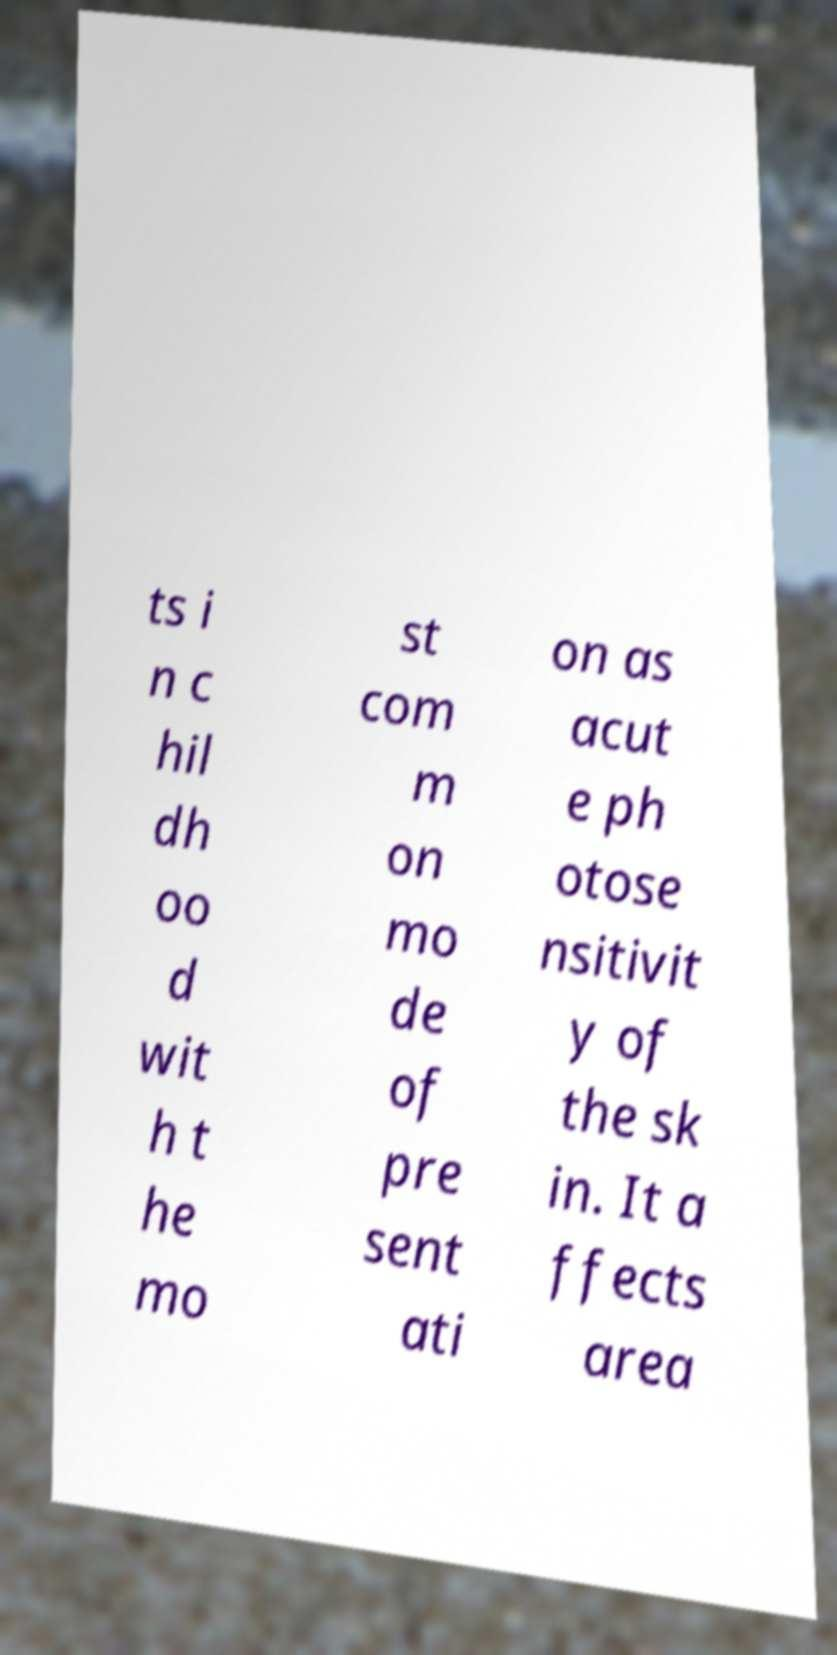Please identify and transcribe the text found in this image. ts i n c hil dh oo d wit h t he mo st com m on mo de of pre sent ati on as acut e ph otose nsitivit y of the sk in. It a ffects area 